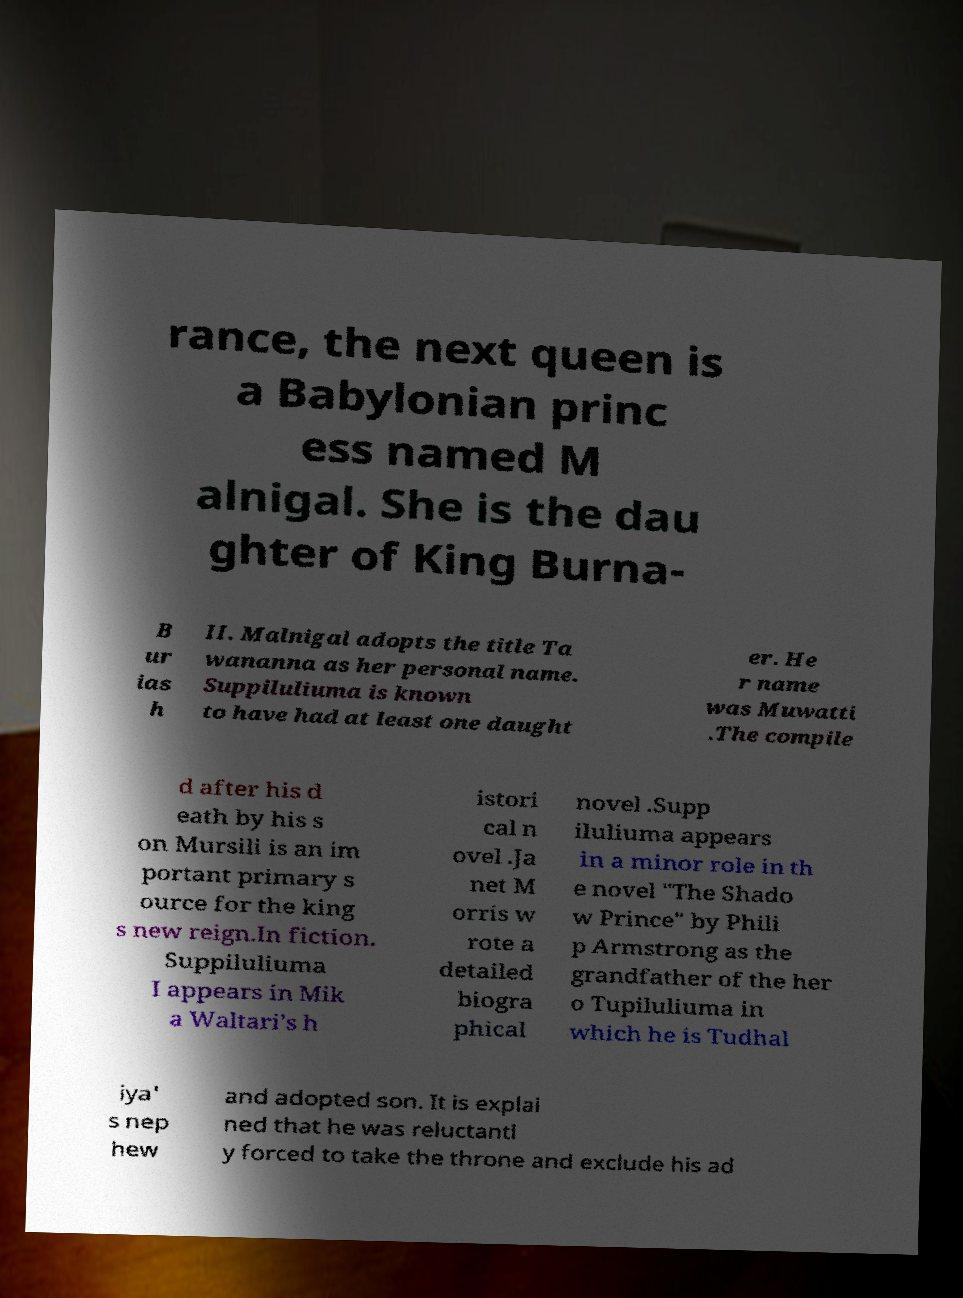What messages or text are displayed in this image? I need them in a readable, typed format. rance, the next queen is a Babylonian princ ess named M alnigal. She is the dau ghter of King Burna- B ur ias h II. Malnigal adopts the title Ta wananna as her personal name. Suppiluliuma is known to have had at least one daught er. He r name was Muwatti .The compile d after his d eath by his s on Mursili is an im portant primary s ource for the king s new reign.In fiction. Suppiluliuma I appears in Mik a Waltari's h istori cal n ovel .Ja net M orris w rote a detailed biogra phical novel .Supp iluliuma appears in a minor role in th e novel "The Shado w Prince" by Phili p Armstrong as the grandfather of the her o Tupiluliuma in which he is Tudhal iya' s nep hew and adopted son. It is explai ned that he was reluctantl y forced to take the throne and exclude his ad 